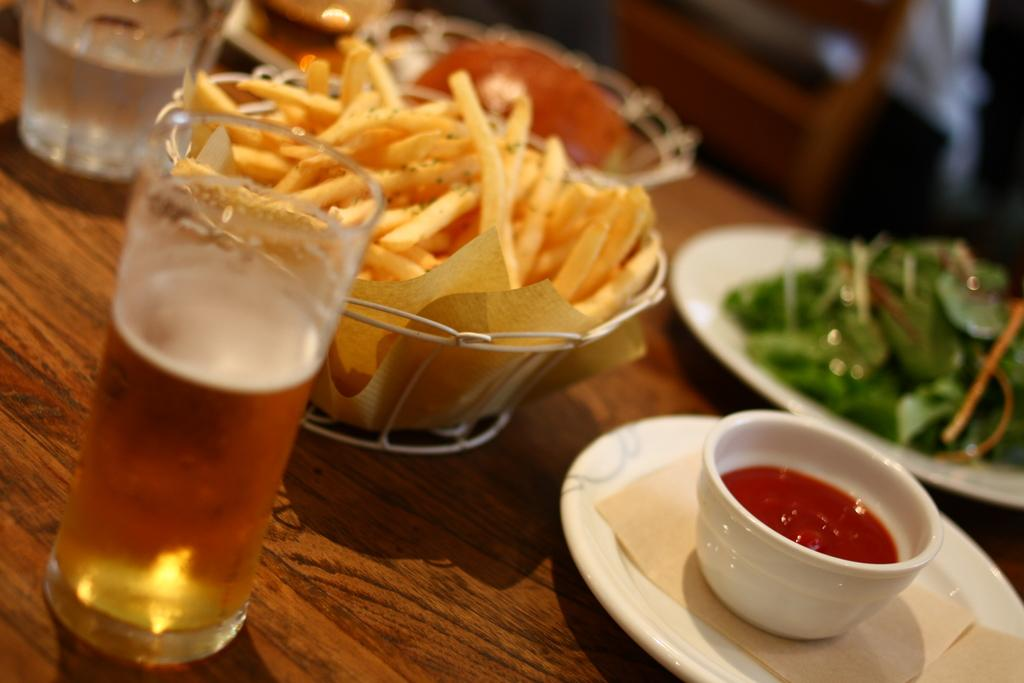What type of glass is visible in the image? There is a wine glass in the image. What type of food is in the bowl next to the wine glass? There is a bowl of french fries in the image. What is in the other bowl in the image? There is a bowl of sauce in the image. What other type of food is present in the image? There is a salad in the image. What is the surface that the objects are placed on? The objects are on a wooden table. What type of field is visible in the image? There is no field present in the image. What is the approval rating of the salad in the image? The image does not provide any information about the approval rating of the salad. 